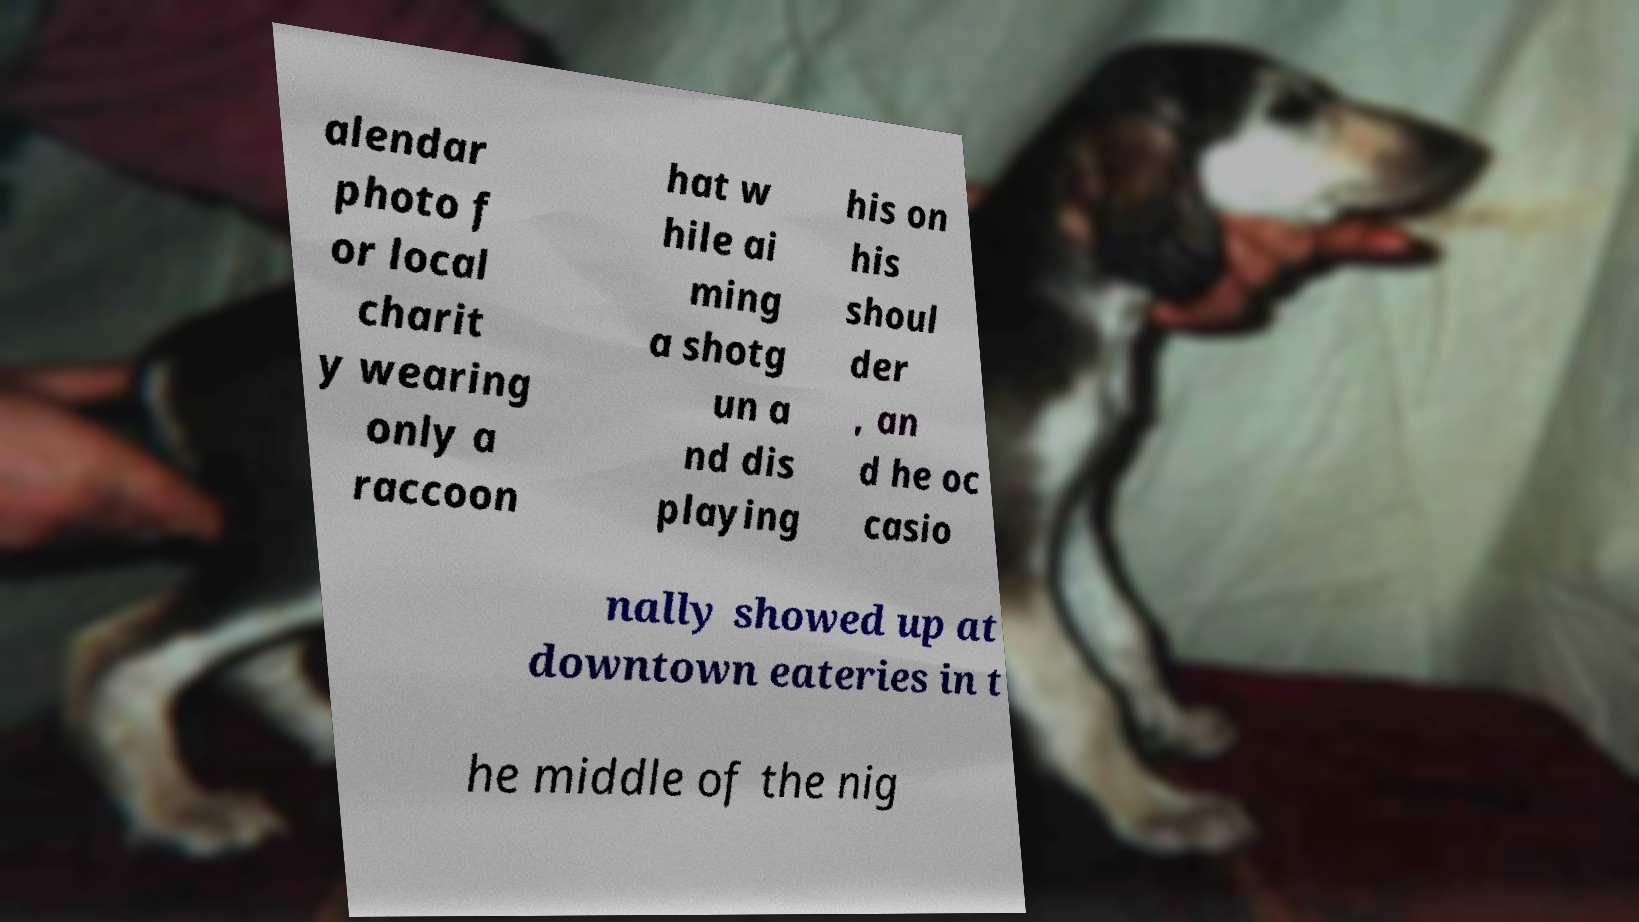Can you read and provide the text displayed in the image?This photo seems to have some interesting text. Can you extract and type it out for me? alendar photo f or local charit y wearing only a raccoon hat w hile ai ming a shotg un a nd dis playing his on his shoul der , an d he oc casio nally showed up at downtown eateries in t he middle of the nig 